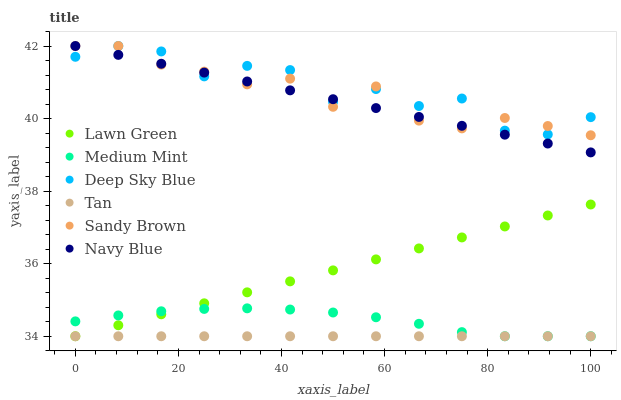Does Tan have the minimum area under the curve?
Answer yes or no. Yes. Does Deep Sky Blue have the maximum area under the curve?
Answer yes or no. Yes. Does Lawn Green have the minimum area under the curve?
Answer yes or no. No. Does Lawn Green have the maximum area under the curve?
Answer yes or no. No. Is Tan the smoothest?
Answer yes or no. Yes. Is Deep Sky Blue the roughest?
Answer yes or no. Yes. Is Lawn Green the smoothest?
Answer yes or no. No. Is Lawn Green the roughest?
Answer yes or no. No. Does Medium Mint have the lowest value?
Answer yes or no. Yes. Does Navy Blue have the lowest value?
Answer yes or no. No. Does Sandy Brown have the highest value?
Answer yes or no. Yes. Does Lawn Green have the highest value?
Answer yes or no. No. Is Lawn Green less than Deep Sky Blue?
Answer yes or no. Yes. Is Deep Sky Blue greater than Tan?
Answer yes or no. Yes. Does Deep Sky Blue intersect Navy Blue?
Answer yes or no. Yes. Is Deep Sky Blue less than Navy Blue?
Answer yes or no. No. Is Deep Sky Blue greater than Navy Blue?
Answer yes or no. No. Does Lawn Green intersect Deep Sky Blue?
Answer yes or no. No. 